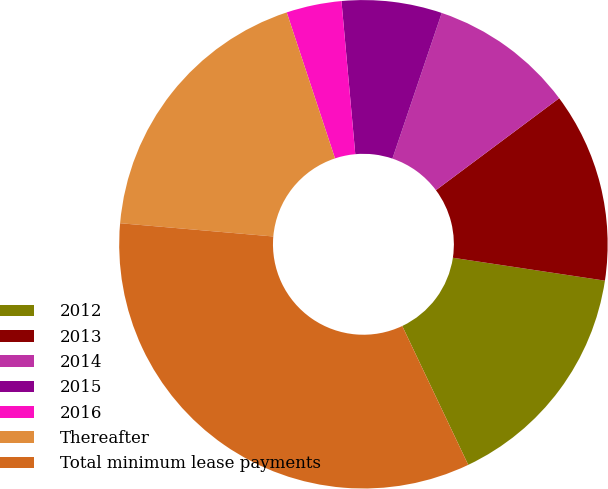Convert chart. <chart><loc_0><loc_0><loc_500><loc_500><pie_chart><fcel>2012<fcel>2013<fcel>2014<fcel>2015<fcel>2016<fcel>Thereafter<fcel>Total minimum lease payments<nl><fcel>15.56%<fcel>12.58%<fcel>9.6%<fcel>6.63%<fcel>3.65%<fcel>18.54%<fcel>33.43%<nl></chart> 